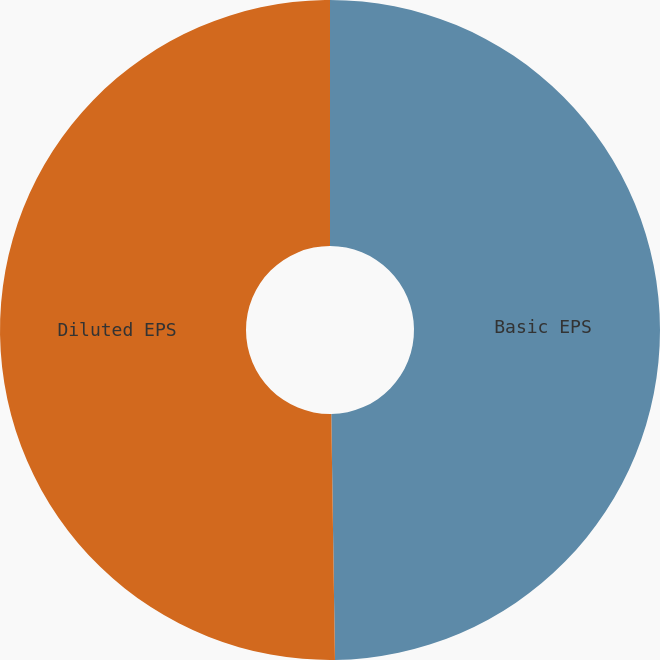<chart> <loc_0><loc_0><loc_500><loc_500><pie_chart><fcel>Basic EPS<fcel>Diluted EPS<nl><fcel>49.76%<fcel>50.24%<nl></chart> 